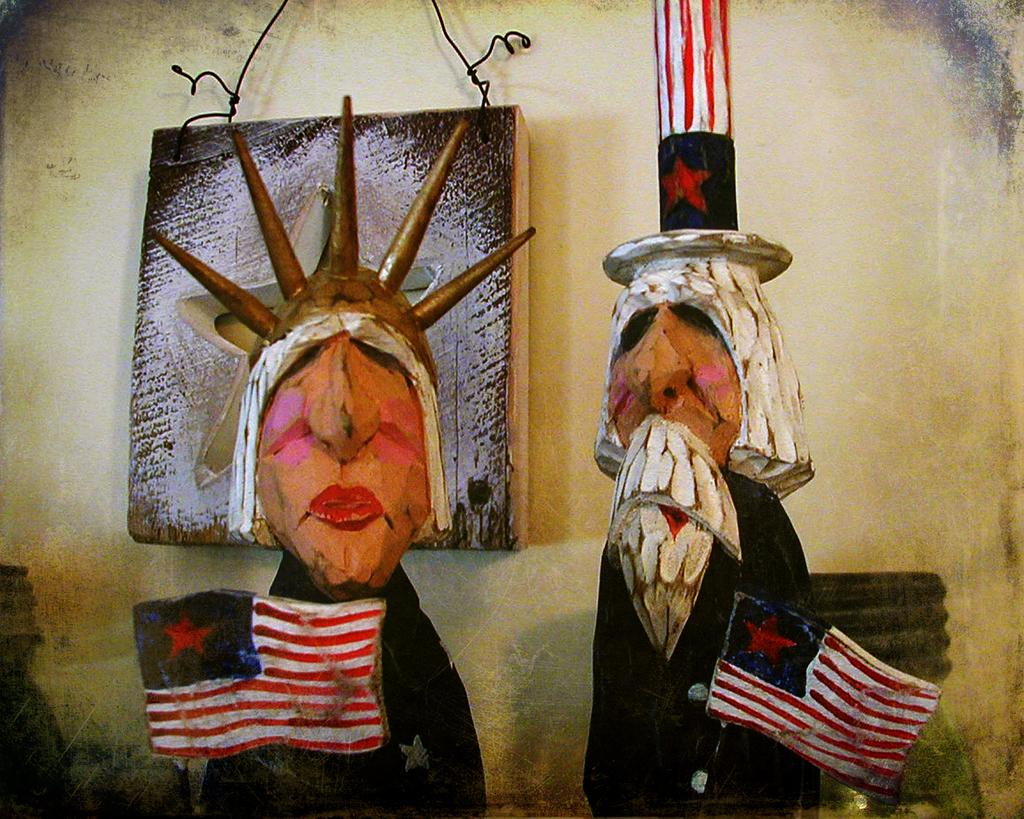What type of objects can be seen in the image? There are two wooden carvings in the image. What is visible in the background of the image? There is a wall in the background of the image. Can you describe any other elements in the image? Yes, there is a wire visible in the image. How many children are holding honey in the image? There are no children or honey present in the image. What type of wing is attached to the wooden carvings in the image? There are no wings attached to the wooden carvings in the carvings in the image. 